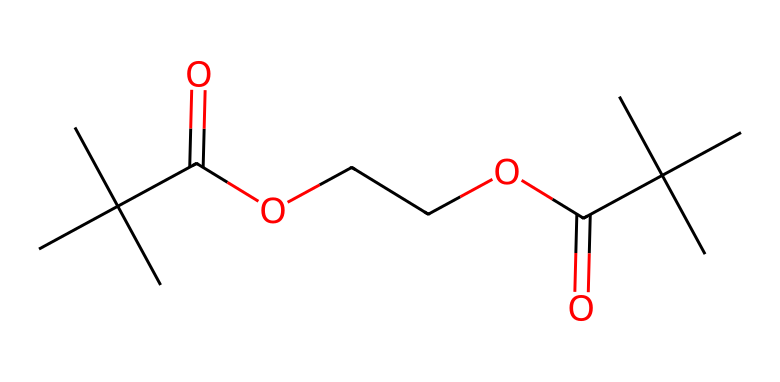What is the total number of carbon atoms in the chemical? By analyzing the SMILES representation, we can count the occurrences of the letter 'C', which stands for carbon. In this structure, there are 12 instances of 'C', indicating that there are 12 carbon atoms present in the molecule.
Answer: 12 How many ester functional groups are present in the chemical? The presence of the ester functional group can be identified by looking for carbonyl groups (C=O) adjacent to an ether or alcohol (–O–) characteristic. There are two such arrangements in the given structure, indicating the presence of two ester groups within the molecule.
Answer: 2 What is the functional group present at the end of the chain? The functional groups can be identified by analyzing the substituents at either end of the molecule. The ending part of the structure features an ester (–C(=O)O–), therefore identifying this as the terminal functional group.
Answer: ester How does the branched structure of the molecule affect its properties? The branched nature of the molecule, indicated by the presence of several tertiary carbon centers, generally leads to lower melting and boiling points compared to their straight-chain counterparts. This structural feature results in increased fluidity, which contributes to its potential use in producing modern plastics.
Answer: lowers melting and boiling points What type of plastic could be derived from this chemical composition? Given that the chemical structure consists of ester functional groups and a branched-cyclic structure, it can be classified as a polyester, commonly used to create various environmentally-friendly plastics applied in furniture manufacturing.
Answer: polyester Identify any potential environmental advantage for using this chemical in office furniture manufacturing. The fused ester structure allows for biodegradability and lower toxicity compared to traditional plastics, presenting an environmentally-friendly alternative important in modern chair manufacturing.
Answer: biodegradability 